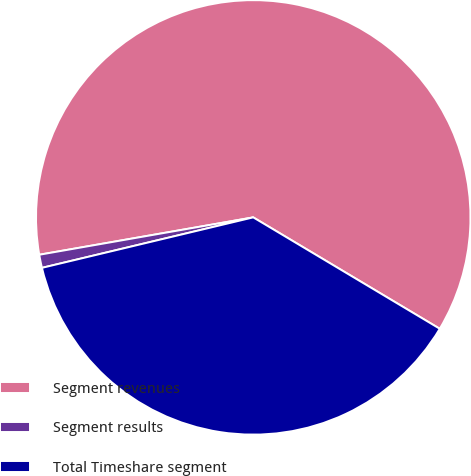<chart> <loc_0><loc_0><loc_500><loc_500><pie_chart><fcel>Segment revenues<fcel>Segment results<fcel>Total Timeshare segment<nl><fcel>61.32%<fcel>0.98%<fcel>37.7%<nl></chart> 